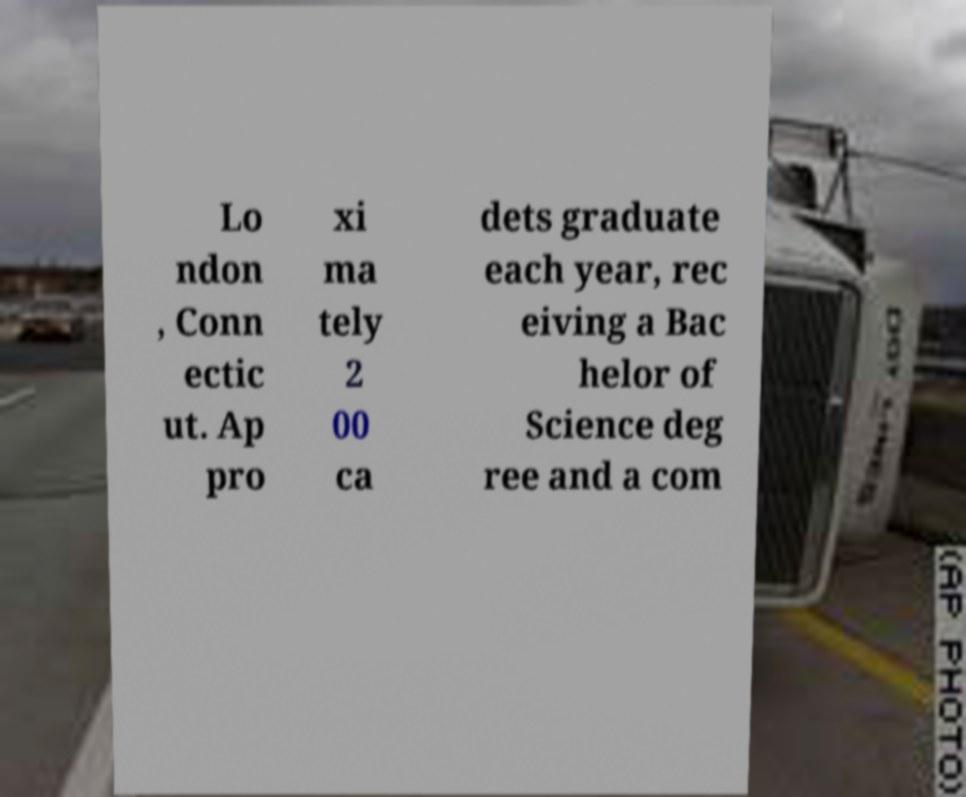For documentation purposes, I need the text within this image transcribed. Could you provide that? Lo ndon , Conn ectic ut. Ap pro xi ma tely 2 00 ca dets graduate each year, rec eiving a Bac helor of Science deg ree and a com 